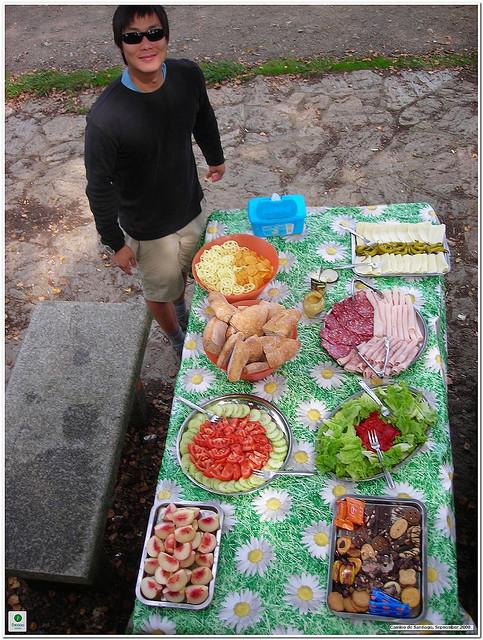How many people is coming to this picnic?
Quick response, please. 1. What is on the plate surrounded by cucumbers?
Short answer required. Tomatoes. Is there a photo effect on the image?
Answer briefly. No. What color is the man's shirt?
Concise answer only. Black. How many people are seated?
Quick response, please. 0. 